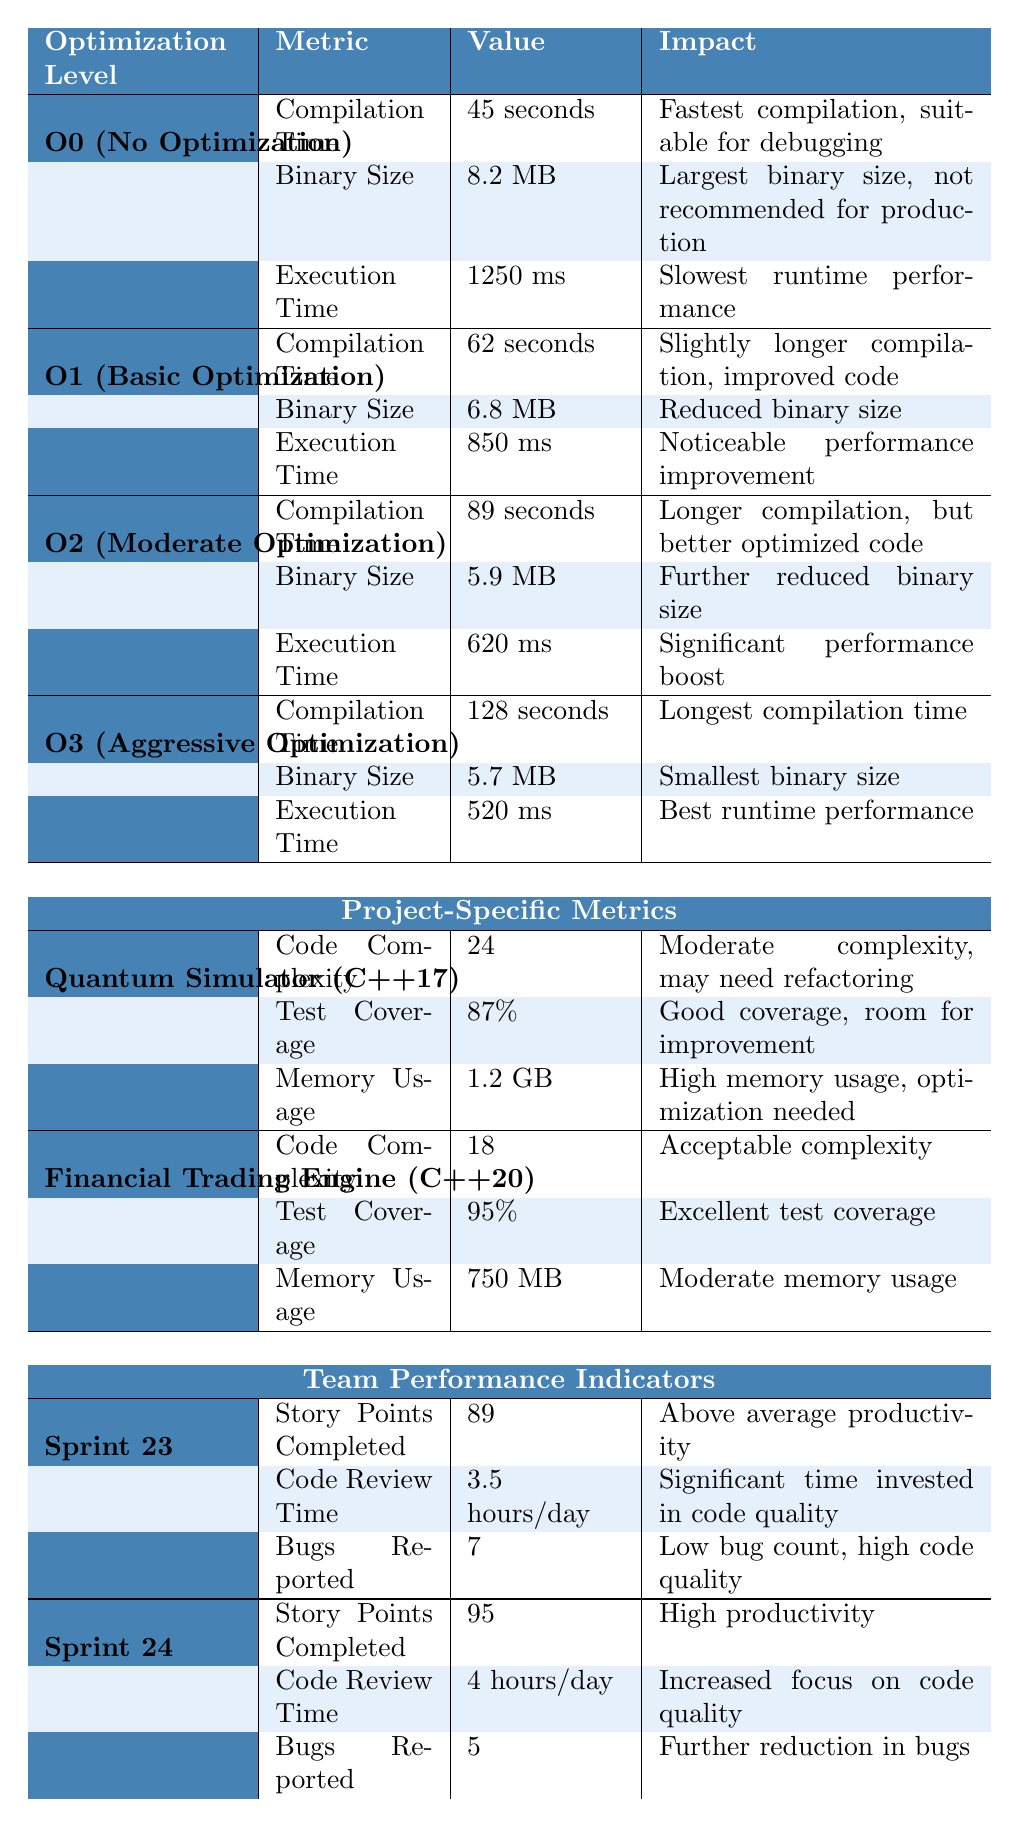What is the compilation time for O2 optimization? The table indicates the compilation time for O2 optimization specifically, which states "89 seconds" next to it.
Answer: 89 seconds What is the execution time for the Financial Trading Engine project? The "Execution Time" metric is listed under the "Financial Trading Engine" project, and it shows a value of "not provided" since the execution time specifically is not detailed in the table.
Answer: Not applicable Which optimization level has the smallest binary size? According to the table, the binary size is "5.7 MB" for O3 optimization, while all other levels have larger binary sizes.
Answer: O3 What is the difference in execution time between O0 and O3 optimization levels? The execution time for O0 is "1250 ms" and for O3 is "520 ms." To find the difference, subtract 520 from 1250, which gives 730 ms.
Answer: 730 ms Is the test coverage for the Quantum Simulator project higher than 90%? The table shows that the test coverage for the Quantum Simulator is "87%," which is less than 90%. Therefore, the answer is no.
Answer: No What is the average compilation time across all optimization levels? The compilation times are 45 seconds for O0, 62 seconds for O1, 89 seconds for O2, and 128 seconds for O3. Summing these gives 324 seconds, and dividing by 4 (the number of optimization levels) gives 81 seconds.
Answer: 81 seconds How many bugs were reported in Sprint 24 compared to Sprint 23? In Sprint 23, there were 7 bugs reported, and in Sprint 24, there were 5. The difference is 7 - 5 = 2, indicating fewer bugs in Sprint 24.
Answer: 2 fewer bugs What is the impact of moving from O1 to O2 optimization on execution time? O1 has an execution time of "850 ms," while O2 has "620 ms." The improvement is 850 - 620 = 230 ms, indicating faster execution time.
Answer: Improvement of 230 ms Does the Financial Trading Engine have better test coverage compared to the Quantum Simulator? The Financial Trading Engine has "95%," while the Quantum Simulator has "87%." Since 95% is greater than 87%, the answer is yes.
Answer: Yes How does the memory usage of the Quantum Simulator compare to the Financial Trading Engine? The Quantum Simulator uses "1.2 GB," and the Financial Trading Engine uses "750 MB." To compare, 1.2 GB is greater than 750 MB, indicating higher memory usage for the Quantum Simulator.
Answer: Higher usage for Quantum Simulator 